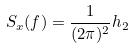<formula> <loc_0><loc_0><loc_500><loc_500>S _ { x } ( f ) = \frac { 1 } { ( 2 \pi ) ^ { 2 } } h _ { 2 }</formula> 